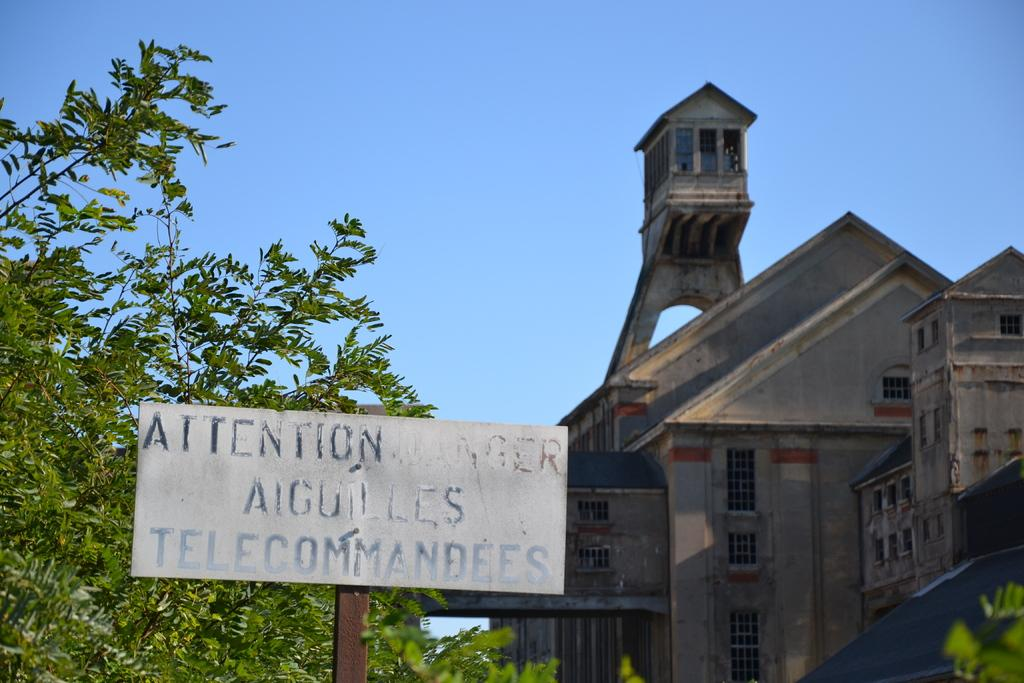What can be found on the left side of the image? There are three objects and a board on the left side of the image. Can you describe the board on the left side of the image? The board is located on the left side of the image. What is visible on the right side of the image? There is a building on the right side of the image. What can be seen in the background of the image? The sky is visible in the background of the image. Where is the line of sugar located in the image? There is no line of sugar present in the image. Is there a cave visible in the image? There is no cave present in the image. 